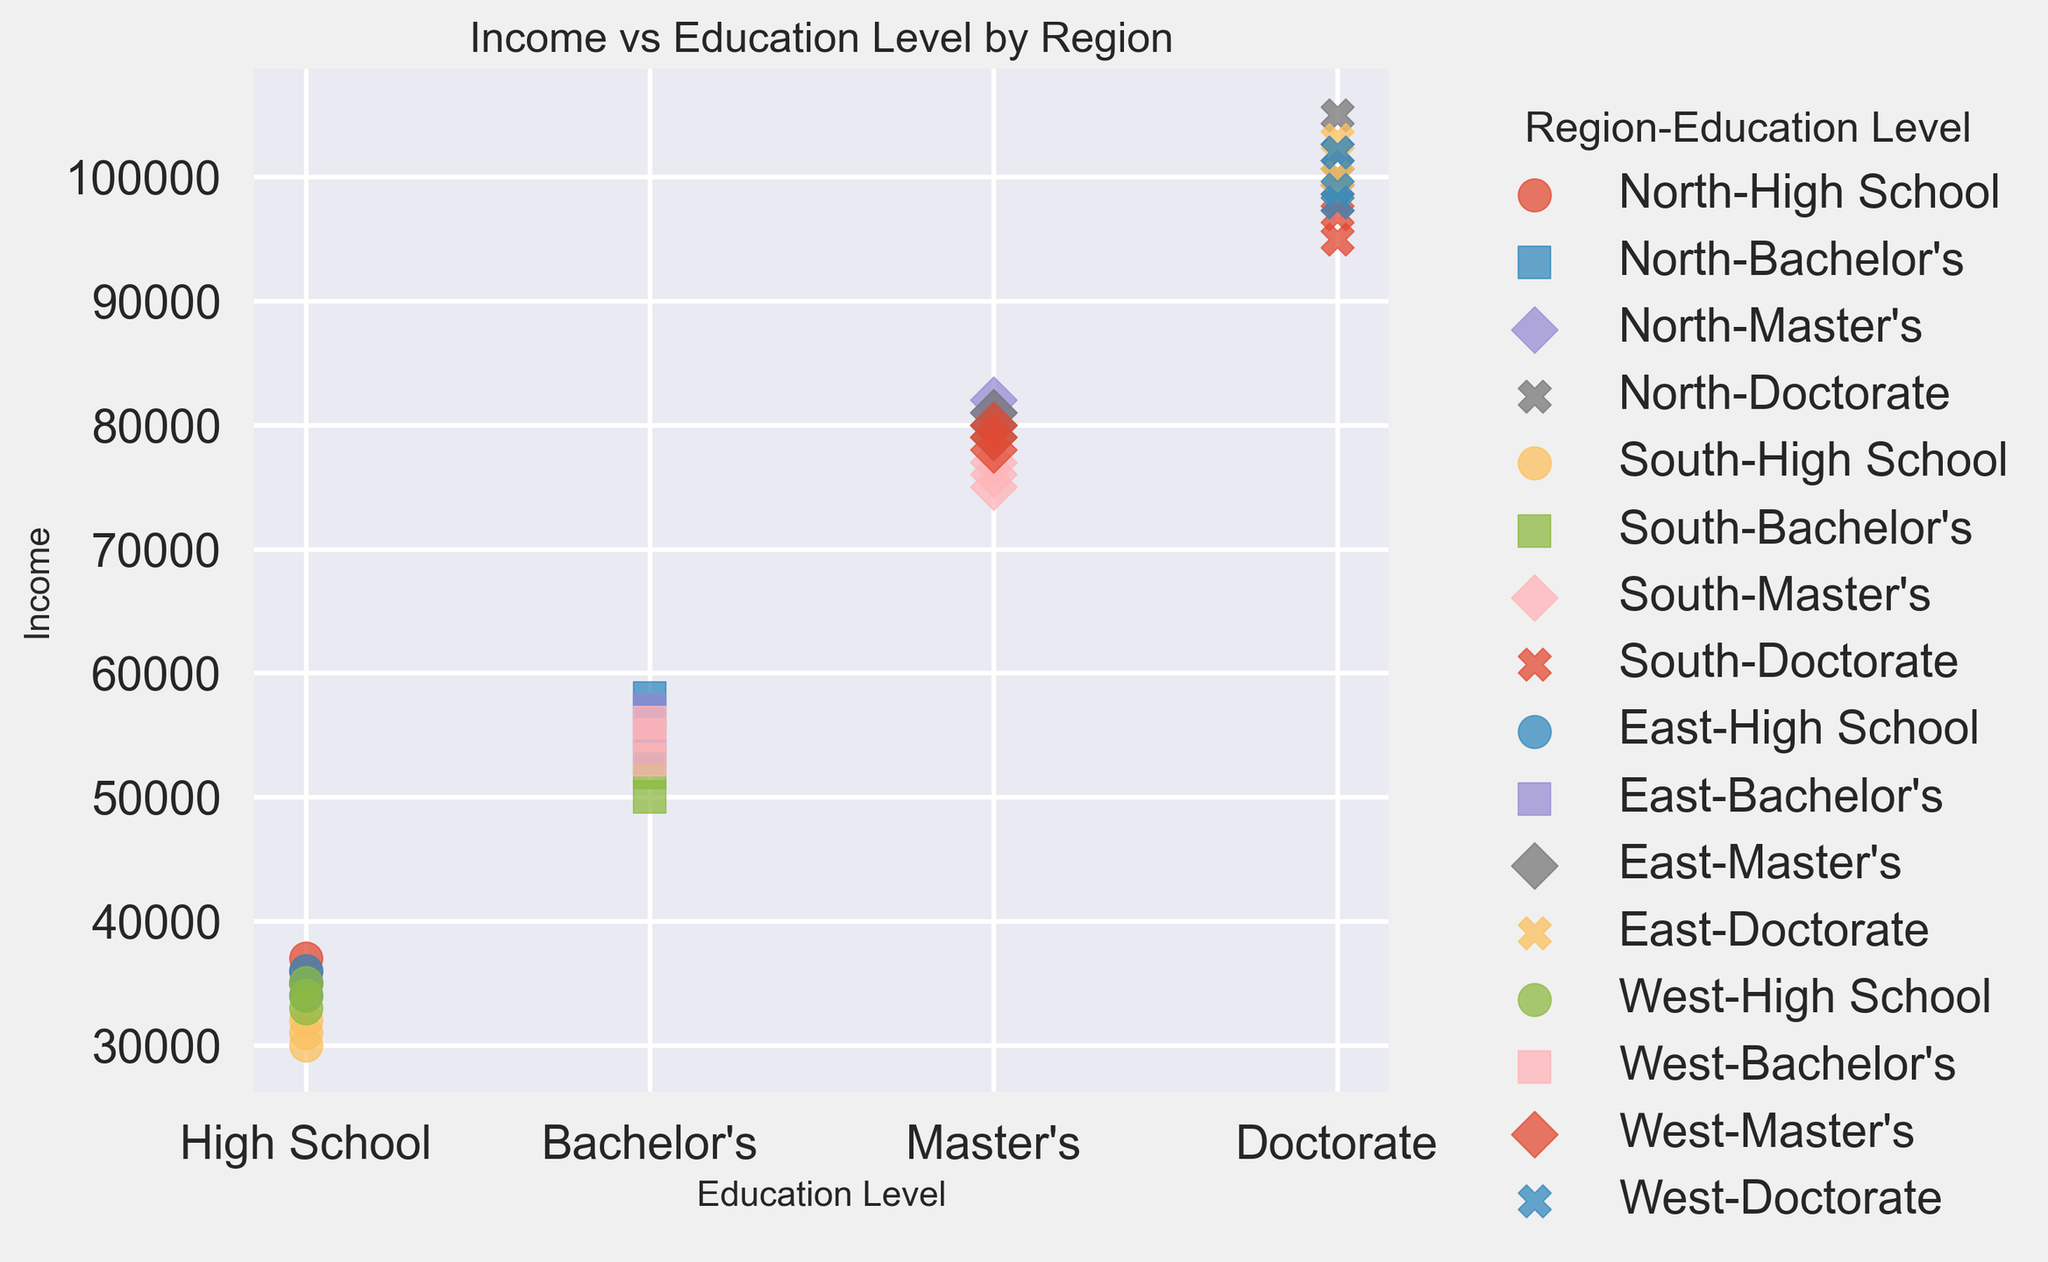Which education level shows the highest income in the North region? To find the highest income within the North region, look for the marker with the highest y-value (income) for each education level. The Doctorate level has the highest y-value within the North region.
Answer: Doctorate Compare the median income for Master's degrees between the East and West regions. Identify the markers corresponding to Master's degrees in both East and West regions and compute their median values. The median incomes for the East and West regions are the middle values of the sorted incomes for Master's degrees. East: 80000, West: 79000
Answer: East: 80000, West: 79000 Which region has the highest-income variance for Bachelor's degrees? To find the region with the highest-income variance for Bachelor's degrees, examine the spread of the y-values for Bachelor's degrees across all regions. The North region shows the widest spread, indicating the highest variance.
Answer: North Which education level appears to have the most consistent income distribution across all regions? The most consistent income distribution could be observed by noticing which education level has markers closest to each other across all regions. "High School" appears to have the least spread in the y-values across regions.
Answer: High School Is the average income for a Doctorate higher in the North or South region? Compute the average income for Doctorate degrees in both the North and South regions. North: (100000 + 105000 + 102000)/3, South: (95000 + 98000 + 97000)/3. North's average: 102333, South's average: 96666.67
Answer: North Which region has the lowest average income for High School graduates? Calculate the average income for High School graduates in each region. The South region has the lowest average since the y-values for South High School graduates are generally lower than other regions. South average: (30000 + 32000 + 31000)/3 = 31000
Answer: South What is the visual marker used for Master’s degrees on the plot? To determine the visual marker for Master’s degrees, identify the shape associated with the income values of Master’s degrees across all regions. The marker is a diamond shape ('D') on the plot.
Answer: Diamond Which region shows the highest average income increment when moving from Bachelor's to Master's degrees? Calculate the average increment for each region by taking the difference between the average income of Master’s and Bachelor’s degrees. For example, in the North: (80000+82000+81000)/3 - (55000+58000+57000)/3 = 25333. Do this for each region and compare. North: 25333, South: 24000, East: 25000, West: 25000. The North has the highest increment.
Answer: North 